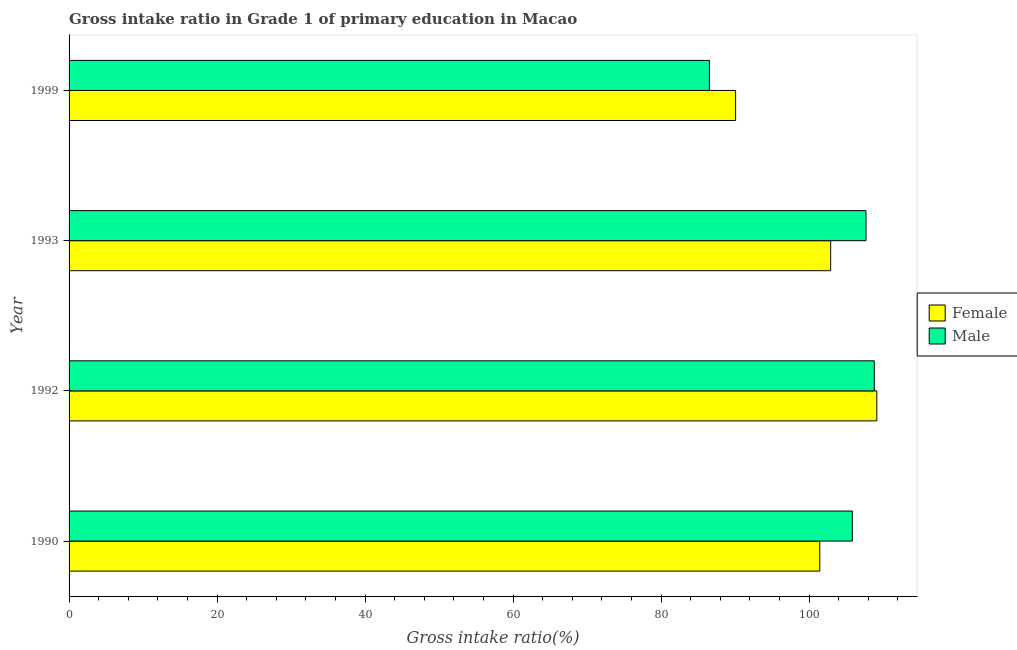Are the number of bars per tick equal to the number of legend labels?
Ensure brevity in your answer.  Yes. Are the number of bars on each tick of the Y-axis equal?
Offer a terse response. Yes. How many bars are there on the 4th tick from the bottom?
Your response must be concise. 2. What is the label of the 1st group of bars from the top?
Your response must be concise. 1999. What is the gross intake ratio(female) in 1999?
Make the answer very short. 90.07. Across all years, what is the maximum gross intake ratio(male)?
Offer a terse response. 108.81. Across all years, what is the minimum gross intake ratio(female)?
Ensure brevity in your answer.  90.07. In which year was the gross intake ratio(male) minimum?
Provide a succinct answer. 1999. What is the total gross intake ratio(female) in the graph?
Your answer should be compact. 403.56. What is the difference between the gross intake ratio(female) in 1992 and that in 1993?
Provide a succinct answer. 6.24. What is the difference between the gross intake ratio(female) in 1999 and the gross intake ratio(male) in 1993?
Your answer should be compact. -17.62. What is the average gross intake ratio(female) per year?
Give a very brief answer. 100.89. In the year 1999, what is the difference between the gross intake ratio(female) and gross intake ratio(male)?
Provide a short and direct response. 3.54. In how many years, is the gross intake ratio(female) greater than 60 %?
Offer a very short reply. 4. Is the difference between the gross intake ratio(female) in 1990 and 1992 greater than the difference between the gross intake ratio(male) in 1990 and 1992?
Your answer should be very brief. No. What is the difference between the highest and the second highest gross intake ratio(male)?
Your answer should be very brief. 1.12. What is the difference between the highest and the lowest gross intake ratio(female)?
Ensure brevity in your answer.  19.08. In how many years, is the gross intake ratio(male) greater than the average gross intake ratio(male) taken over all years?
Your response must be concise. 3. Is the sum of the gross intake ratio(male) in 1990 and 1993 greater than the maximum gross intake ratio(female) across all years?
Your answer should be very brief. Yes. What does the 2nd bar from the top in 1999 represents?
Your answer should be very brief. Female. Are all the bars in the graph horizontal?
Your response must be concise. Yes. What is the difference between two consecutive major ticks on the X-axis?
Keep it short and to the point. 20. Are the values on the major ticks of X-axis written in scientific E-notation?
Give a very brief answer. No. Does the graph contain any zero values?
Give a very brief answer. No. Does the graph contain grids?
Provide a short and direct response. No. What is the title of the graph?
Provide a succinct answer. Gross intake ratio in Grade 1 of primary education in Macao. Does "Chemicals" appear as one of the legend labels in the graph?
Your answer should be compact. No. What is the label or title of the X-axis?
Offer a very short reply. Gross intake ratio(%). What is the label or title of the Y-axis?
Provide a short and direct response. Year. What is the Gross intake ratio(%) in Female in 1990?
Make the answer very short. 101.44. What is the Gross intake ratio(%) in Male in 1990?
Keep it short and to the point. 105.84. What is the Gross intake ratio(%) of Female in 1992?
Offer a very short reply. 109.15. What is the Gross intake ratio(%) of Male in 1992?
Ensure brevity in your answer.  108.81. What is the Gross intake ratio(%) of Female in 1993?
Your answer should be very brief. 102.91. What is the Gross intake ratio(%) in Male in 1993?
Your response must be concise. 107.69. What is the Gross intake ratio(%) of Female in 1999?
Provide a short and direct response. 90.07. What is the Gross intake ratio(%) in Male in 1999?
Keep it short and to the point. 86.53. Across all years, what is the maximum Gross intake ratio(%) of Female?
Give a very brief answer. 109.15. Across all years, what is the maximum Gross intake ratio(%) in Male?
Your answer should be very brief. 108.81. Across all years, what is the minimum Gross intake ratio(%) in Female?
Offer a terse response. 90.07. Across all years, what is the minimum Gross intake ratio(%) in Male?
Make the answer very short. 86.53. What is the total Gross intake ratio(%) of Female in the graph?
Give a very brief answer. 403.56. What is the total Gross intake ratio(%) in Male in the graph?
Provide a succinct answer. 408.86. What is the difference between the Gross intake ratio(%) in Female in 1990 and that in 1992?
Your response must be concise. -7.71. What is the difference between the Gross intake ratio(%) in Male in 1990 and that in 1992?
Your response must be concise. -2.97. What is the difference between the Gross intake ratio(%) in Female in 1990 and that in 1993?
Ensure brevity in your answer.  -1.47. What is the difference between the Gross intake ratio(%) of Male in 1990 and that in 1993?
Make the answer very short. -1.85. What is the difference between the Gross intake ratio(%) in Female in 1990 and that in 1999?
Offer a terse response. 11.37. What is the difference between the Gross intake ratio(%) of Male in 1990 and that in 1999?
Give a very brief answer. 19.31. What is the difference between the Gross intake ratio(%) of Female in 1992 and that in 1993?
Provide a short and direct response. 6.23. What is the difference between the Gross intake ratio(%) of Male in 1992 and that in 1993?
Offer a very short reply. 1.12. What is the difference between the Gross intake ratio(%) in Female in 1992 and that in 1999?
Your answer should be very brief. 19.08. What is the difference between the Gross intake ratio(%) in Male in 1992 and that in 1999?
Offer a very short reply. 22.28. What is the difference between the Gross intake ratio(%) in Female in 1993 and that in 1999?
Keep it short and to the point. 12.85. What is the difference between the Gross intake ratio(%) in Male in 1993 and that in 1999?
Ensure brevity in your answer.  21.16. What is the difference between the Gross intake ratio(%) in Female in 1990 and the Gross intake ratio(%) in Male in 1992?
Keep it short and to the point. -7.37. What is the difference between the Gross intake ratio(%) in Female in 1990 and the Gross intake ratio(%) in Male in 1993?
Offer a very short reply. -6.25. What is the difference between the Gross intake ratio(%) in Female in 1990 and the Gross intake ratio(%) in Male in 1999?
Keep it short and to the point. 14.91. What is the difference between the Gross intake ratio(%) of Female in 1992 and the Gross intake ratio(%) of Male in 1993?
Provide a short and direct response. 1.46. What is the difference between the Gross intake ratio(%) in Female in 1992 and the Gross intake ratio(%) in Male in 1999?
Offer a terse response. 22.62. What is the difference between the Gross intake ratio(%) in Female in 1993 and the Gross intake ratio(%) in Male in 1999?
Make the answer very short. 16.38. What is the average Gross intake ratio(%) in Female per year?
Offer a very short reply. 100.89. What is the average Gross intake ratio(%) in Male per year?
Offer a terse response. 102.22. In the year 1990, what is the difference between the Gross intake ratio(%) in Female and Gross intake ratio(%) in Male?
Give a very brief answer. -4.4. In the year 1992, what is the difference between the Gross intake ratio(%) in Female and Gross intake ratio(%) in Male?
Offer a terse response. 0.34. In the year 1993, what is the difference between the Gross intake ratio(%) in Female and Gross intake ratio(%) in Male?
Ensure brevity in your answer.  -4.78. In the year 1999, what is the difference between the Gross intake ratio(%) of Female and Gross intake ratio(%) of Male?
Provide a short and direct response. 3.53. What is the ratio of the Gross intake ratio(%) in Female in 1990 to that in 1992?
Keep it short and to the point. 0.93. What is the ratio of the Gross intake ratio(%) of Male in 1990 to that in 1992?
Your response must be concise. 0.97. What is the ratio of the Gross intake ratio(%) of Female in 1990 to that in 1993?
Make the answer very short. 0.99. What is the ratio of the Gross intake ratio(%) in Male in 1990 to that in 1993?
Make the answer very short. 0.98. What is the ratio of the Gross intake ratio(%) in Female in 1990 to that in 1999?
Your response must be concise. 1.13. What is the ratio of the Gross intake ratio(%) in Male in 1990 to that in 1999?
Offer a very short reply. 1.22. What is the ratio of the Gross intake ratio(%) of Female in 1992 to that in 1993?
Keep it short and to the point. 1.06. What is the ratio of the Gross intake ratio(%) in Male in 1992 to that in 1993?
Your answer should be compact. 1.01. What is the ratio of the Gross intake ratio(%) of Female in 1992 to that in 1999?
Ensure brevity in your answer.  1.21. What is the ratio of the Gross intake ratio(%) in Male in 1992 to that in 1999?
Keep it short and to the point. 1.26. What is the ratio of the Gross intake ratio(%) in Female in 1993 to that in 1999?
Give a very brief answer. 1.14. What is the ratio of the Gross intake ratio(%) of Male in 1993 to that in 1999?
Keep it short and to the point. 1.24. What is the difference between the highest and the second highest Gross intake ratio(%) of Female?
Offer a very short reply. 6.23. What is the difference between the highest and the second highest Gross intake ratio(%) of Male?
Offer a very short reply. 1.12. What is the difference between the highest and the lowest Gross intake ratio(%) of Female?
Make the answer very short. 19.08. What is the difference between the highest and the lowest Gross intake ratio(%) in Male?
Give a very brief answer. 22.28. 